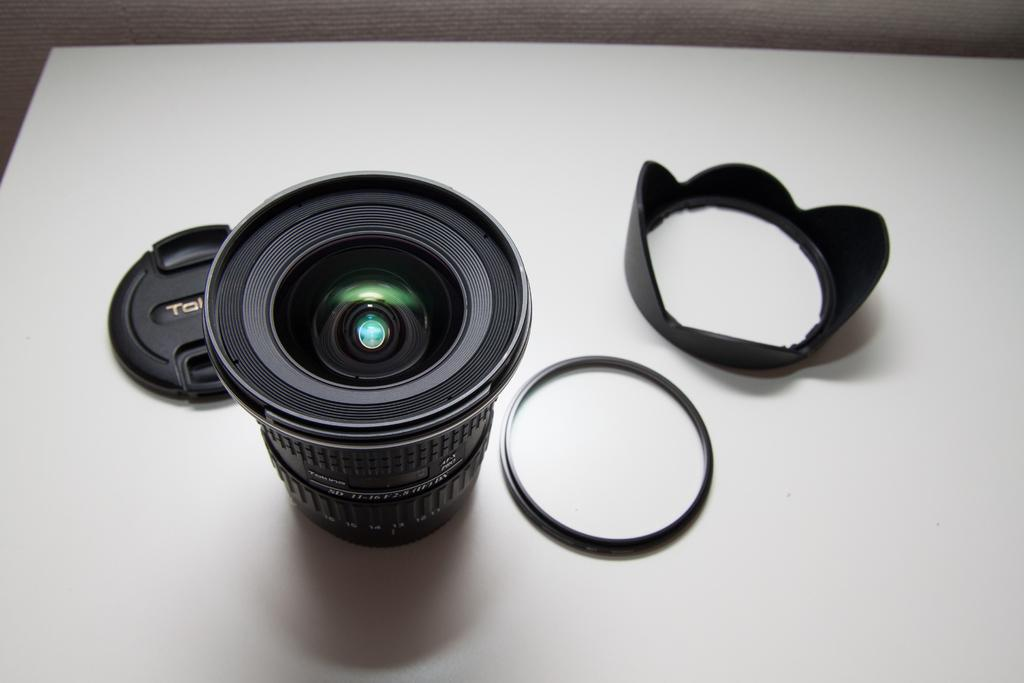What is the main subject of the image? The main subject of the image is a camera lens. What else can be seen in the image besides the camera lens? There are caps and two other objects in the image. What is the color of the surface on which the objects are placed? The objects are on a white-colored surface. What decision is being made in the image? There is no indication of a decision being made in the image; it simply shows a camera lens and other objects on a white surface. 